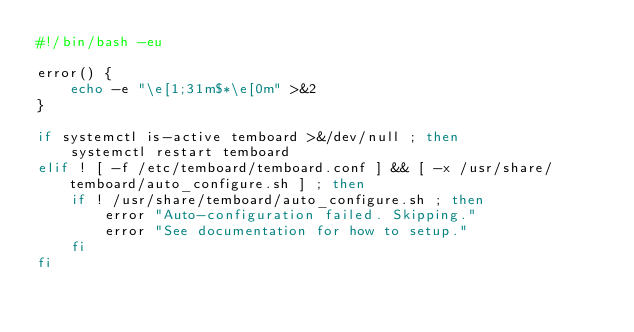<code> <loc_0><loc_0><loc_500><loc_500><_Bash_>#!/bin/bash -eu

error() {
	echo -e "\e[1;31m$*\e[0m" >&2
}

if systemctl is-active temboard >&/dev/null ; then
	systemctl restart temboard
elif ! [ -f /etc/temboard/temboard.conf ] && [ -x /usr/share/temboard/auto_configure.sh ] ; then
	if ! /usr/share/temboard/auto_configure.sh ; then
		error "Auto-configuration failed. Skipping."
		error "See documentation for how to setup."
	fi
fi
</code> 